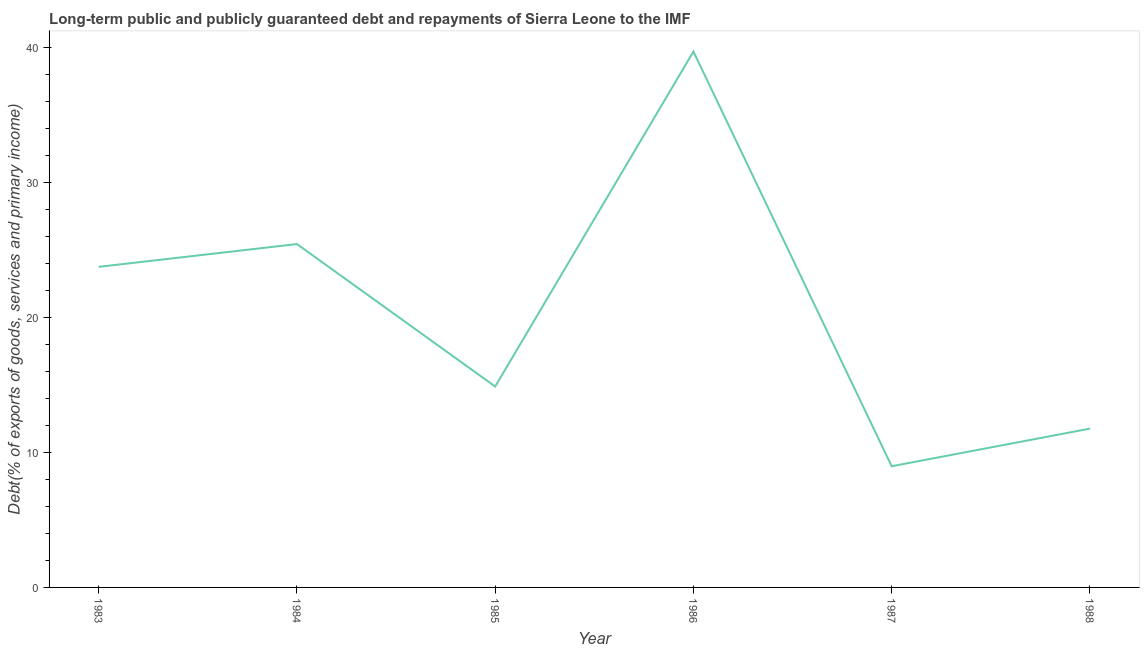What is the debt service in 1987?
Provide a succinct answer. 8.97. Across all years, what is the maximum debt service?
Your answer should be compact. 39.68. Across all years, what is the minimum debt service?
Provide a short and direct response. 8.97. In which year was the debt service maximum?
Your answer should be very brief. 1986. In which year was the debt service minimum?
Make the answer very short. 1987. What is the sum of the debt service?
Make the answer very short. 124.47. What is the difference between the debt service in 1987 and 1988?
Ensure brevity in your answer.  -2.79. What is the average debt service per year?
Your answer should be very brief. 20.74. What is the median debt service?
Provide a succinct answer. 19.31. In how many years, is the debt service greater than 12 %?
Your answer should be compact. 4. Do a majority of the years between 1986 and 1987 (inclusive) have debt service greater than 2 %?
Make the answer very short. Yes. What is the ratio of the debt service in 1983 to that in 1985?
Your answer should be very brief. 1.6. What is the difference between the highest and the second highest debt service?
Your answer should be compact. 14.26. Is the sum of the debt service in 1983 and 1987 greater than the maximum debt service across all years?
Provide a succinct answer. No. What is the difference between the highest and the lowest debt service?
Give a very brief answer. 30.71. In how many years, is the debt service greater than the average debt service taken over all years?
Provide a short and direct response. 3. Does the debt service monotonically increase over the years?
Your answer should be compact. No. How many lines are there?
Provide a short and direct response. 1. How many years are there in the graph?
Offer a very short reply. 6. What is the difference between two consecutive major ticks on the Y-axis?
Provide a short and direct response. 10. Does the graph contain any zero values?
Provide a short and direct response. No. Does the graph contain grids?
Keep it short and to the point. No. What is the title of the graph?
Ensure brevity in your answer.  Long-term public and publicly guaranteed debt and repayments of Sierra Leone to the IMF. What is the label or title of the X-axis?
Make the answer very short. Year. What is the label or title of the Y-axis?
Give a very brief answer. Debt(% of exports of goods, services and primary income). What is the Debt(% of exports of goods, services and primary income) of 1983?
Provide a succinct answer. 23.74. What is the Debt(% of exports of goods, services and primary income) of 1984?
Give a very brief answer. 25.43. What is the Debt(% of exports of goods, services and primary income) in 1985?
Your answer should be very brief. 14.88. What is the Debt(% of exports of goods, services and primary income) of 1986?
Your response must be concise. 39.68. What is the Debt(% of exports of goods, services and primary income) in 1987?
Provide a succinct answer. 8.97. What is the Debt(% of exports of goods, services and primary income) of 1988?
Keep it short and to the point. 11.76. What is the difference between the Debt(% of exports of goods, services and primary income) in 1983 and 1984?
Your response must be concise. -1.69. What is the difference between the Debt(% of exports of goods, services and primary income) in 1983 and 1985?
Your answer should be very brief. 8.86. What is the difference between the Debt(% of exports of goods, services and primary income) in 1983 and 1986?
Your answer should be compact. -15.94. What is the difference between the Debt(% of exports of goods, services and primary income) in 1983 and 1987?
Ensure brevity in your answer.  14.77. What is the difference between the Debt(% of exports of goods, services and primary income) in 1983 and 1988?
Keep it short and to the point. 11.98. What is the difference between the Debt(% of exports of goods, services and primary income) in 1984 and 1985?
Your answer should be compact. 10.55. What is the difference between the Debt(% of exports of goods, services and primary income) in 1984 and 1986?
Your answer should be compact. -14.26. What is the difference between the Debt(% of exports of goods, services and primary income) in 1984 and 1987?
Your answer should be compact. 16.45. What is the difference between the Debt(% of exports of goods, services and primary income) in 1984 and 1988?
Provide a short and direct response. 13.67. What is the difference between the Debt(% of exports of goods, services and primary income) in 1985 and 1986?
Provide a succinct answer. -24.81. What is the difference between the Debt(% of exports of goods, services and primary income) in 1985 and 1987?
Your answer should be compact. 5.9. What is the difference between the Debt(% of exports of goods, services and primary income) in 1985 and 1988?
Provide a succinct answer. 3.12. What is the difference between the Debt(% of exports of goods, services and primary income) in 1986 and 1987?
Give a very brief answer. 30.71. What is the difference between the Debt(% of exports of goods, services and primary income) in 1986 and 1988?
Offer a very short reply. 27.92. What is the difference between the Debt(% of exports of goods, services and primary income) in 1987 and 1988?
Your response must be concise. -2.79. What is the ratio of the Debt(% of exports of goods, services and primary income) in 1983 to that in 1984?
Provide a succinct answer. 0.93. What is the ratio of the Debt(% of exports of goods, services and primary income) in 1983 to that in 1985?
Provide a short and direct response. 1.6. What is the ratio of the Debt(% of exports of goods, services and primary income) in 1983 to that in 1986?
Your response must be concise. 0.6. What is the ratio of the Debt(% of exports of goods, services and primary income) in 1983 to that in 1987?
Ensure brevity in your answer.  2.65. What is the ratio of the Debt(% of exports of goods, services and primary income) in 1983 to that in 1988?
Your answer should be very brief. 2.02. What is the ratio of the Debt(% of exports of goods, services and primary income) in 1984 to that in 1985?
Your response must be concise. 1.71. What is the ratio of the Debt(% of exports of goods, services and primary income) in 1984 to that in 1986?
Make the answer very short. 0.64. What is the ratio of the Debt(% of exports of goods, services and primary income) in 1984 to that in 1987?
Keep it short and to the point. 2.83. What is the ratio of the Debt(% of exports of goods, services and primary income) in 1984 to that in 1988?
Your answer should be compact. 2.16. What is the ratio of the Debt(% of exports of goods, services and primary income) in 1985 to that in 1987?
Keep it short and to the point. 1.66. What is the ratio of the Debt(% of exports of goods, services and primary income) in 1985 to that in 1988?
Keep it short and to the point. 1.26. What is the ratio of the Debt(% of exports of goods, services and primary income) in 1986 to that in 1987?
Ensure brevity in your answer.  4.42. What is the ratio of the Debt(% of exports of goods, services and primary income) in 1986 to that in 1988?
Provide a succinct answer. 3.37. What is the ratio of the Debt(% of exports of goods, services and primary income) in 1987 to that in 1988?
Offer a terse response. 0.76. 